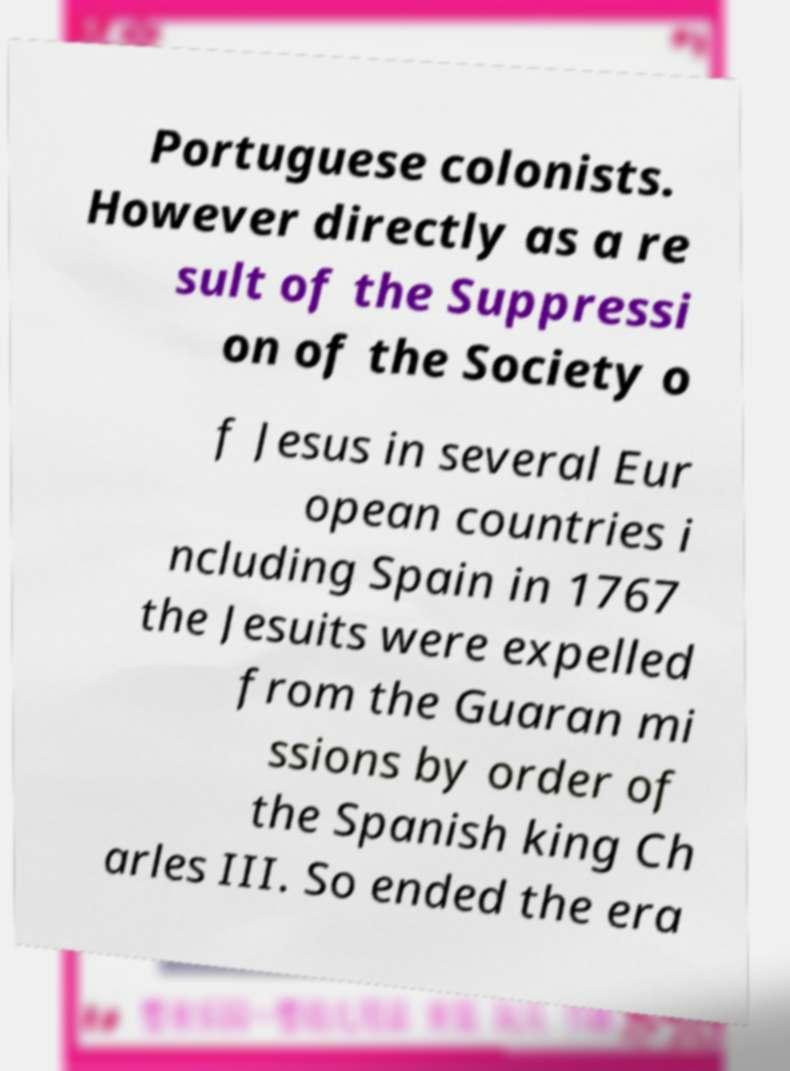Could you extract and type out the text from this image? Portuguese colonists. However directly as a re sult of the Suppressi on of the Society o f Jesus in several Eur opean countries i ncluding Spain in 1767 the Jesuits were expelled from the Guaran mi ssions by order of the Spanish king Ch arles III. So ended the era 